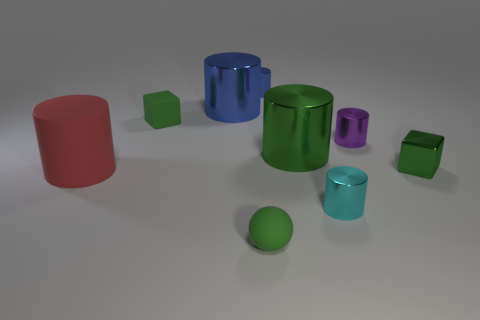Subtract all green shiny cylinders. How many cylinders are left? 5 Subtract 1 cylinders. How many cylinders are left? 5 Subtract all purple cylinders. How many cylinders are left? 5 Add 2 green cylinders. How many green cylinders exist? 3 Subtract 0 red spheres. How many objects are left? 9 Subtract all cylinders. How many objects are left? 3 Subtract all yellow cylinders. Subtract all brown blocks. How many cylinders are left? 6 Subtract all matte things. Subtract all red objects. How many objects are left? 5 Add 6 tiny blue metal cylinders. How many tiny blue metal cylinders are left? 7 